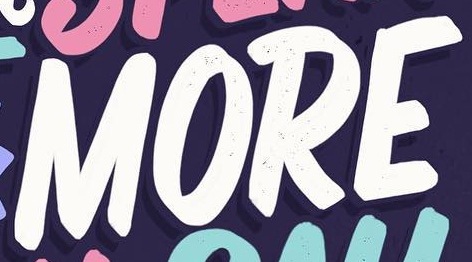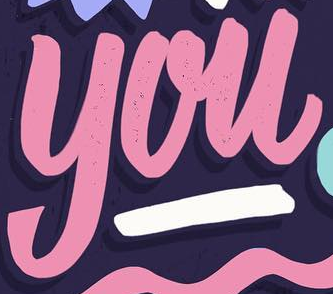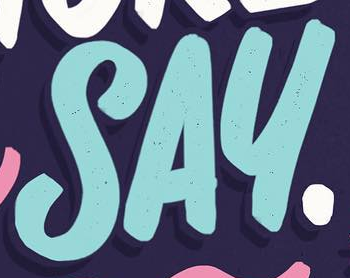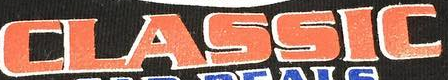Read the text from these images in sequence, separated by a semicolon. MORE; you; SAY; CLASSIC 